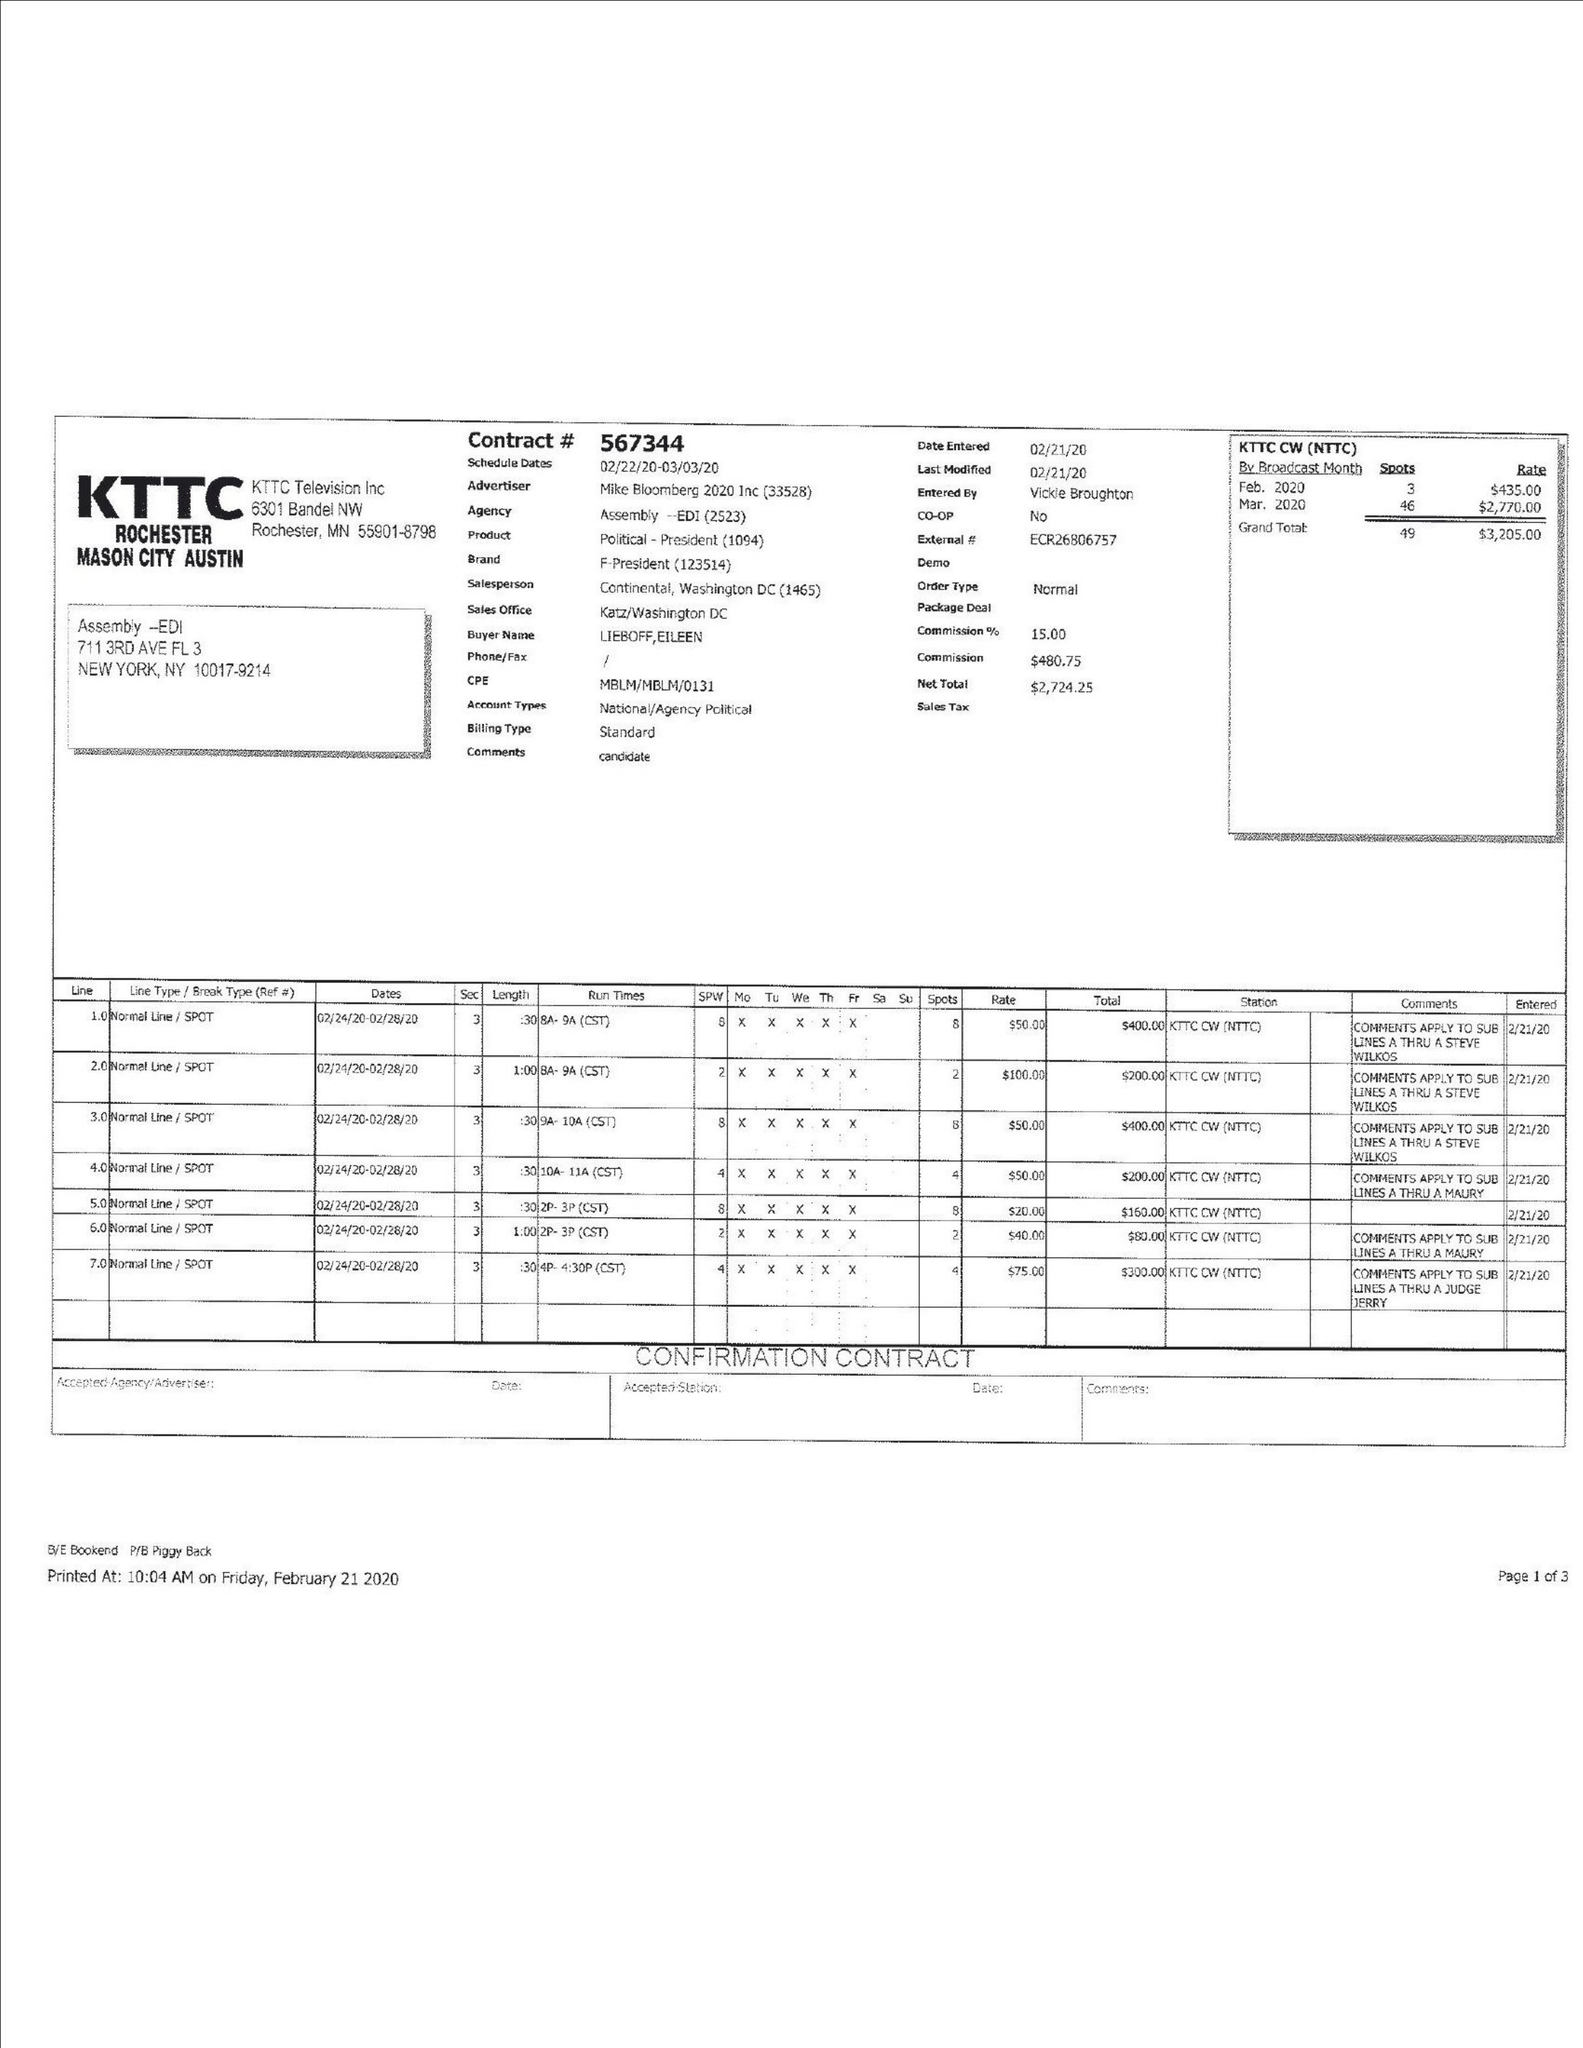What is the value for the advertiser?
Answer the question using a single word or phrase. MIKE BLOOMBERG 2020 INC 